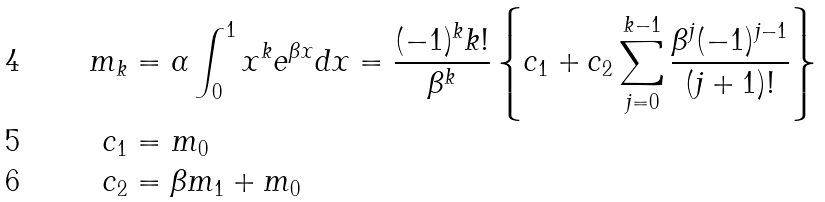Convert formula to latex. <formula><loc_0><loc_0><loc_500><loc_500>m _ { k } & = \alpha \int _ { 0 } ^ { 1 } x ^ { k } e ^ { \beta x } d x = \frac { ( - 1 ) ^ { k } k ! } { \beta ^ { k } } \left \{ c _ { 1 } + c _ { 2 } \sum _ { j = 0 } ^ { k - 1 } \frac { \beta ^ { j } ( - 1 ) ^ { j - 1 } } { ( j + 1 ) ! } \right \} \\ c _ { 1 } & = m _ { 0 } \\ c _ { 2 } & = \beta m _ { 1 } + m _ { 0 }</formula> 